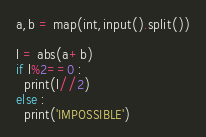<code> <loc_0><loc_0><loc_500><loc_500><_Python_>a,b = map(int,input().split())

l = abs(a+b)
if l%2==0 :
  print(l//2)
else :
  print('IMPOSSIBLE')</code> 